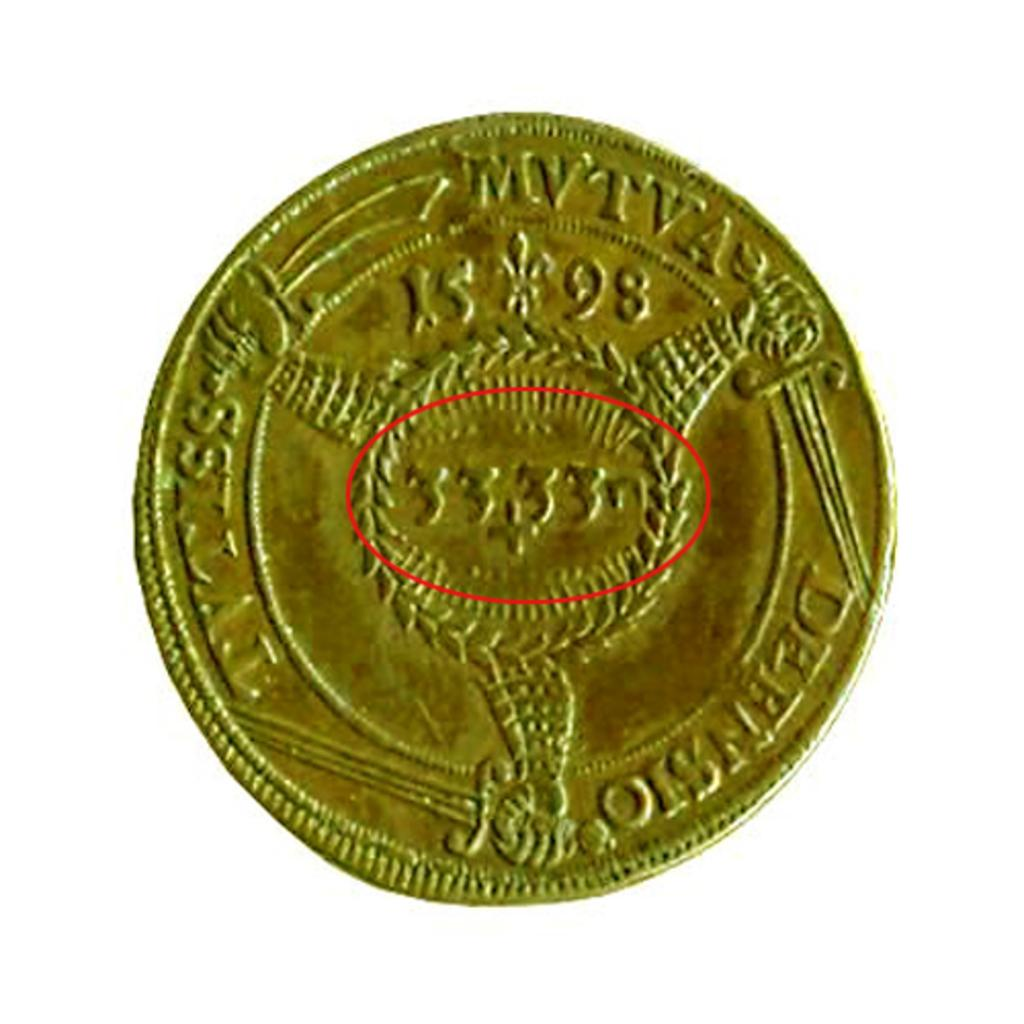<image>
Describe the image concisely. A gold coin with the numbers 15 98 and 33,33 on it. 